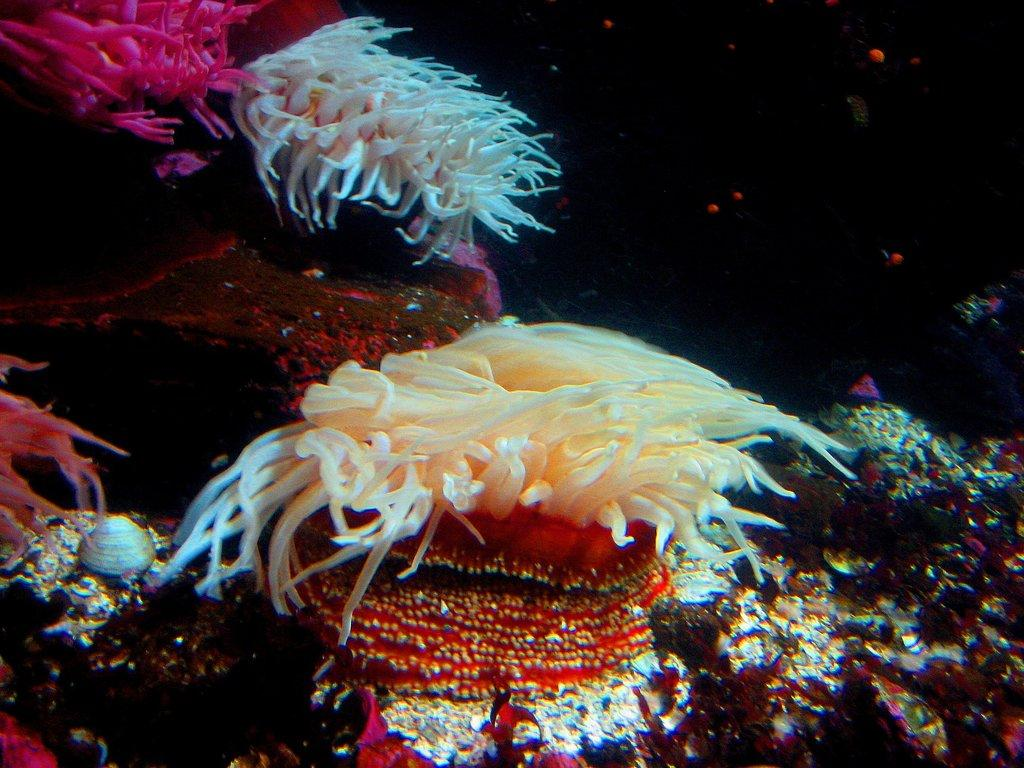What type of underwater environment is depicted in the image? The image features many coral reefs. Are there any other objects or features visible in the image? Yes, there are a few shells in the image. What type of linen is draped over the coral reefs in the image? There is no linen present in the image; it is an underwater scene featuring coral reefs and shells. 